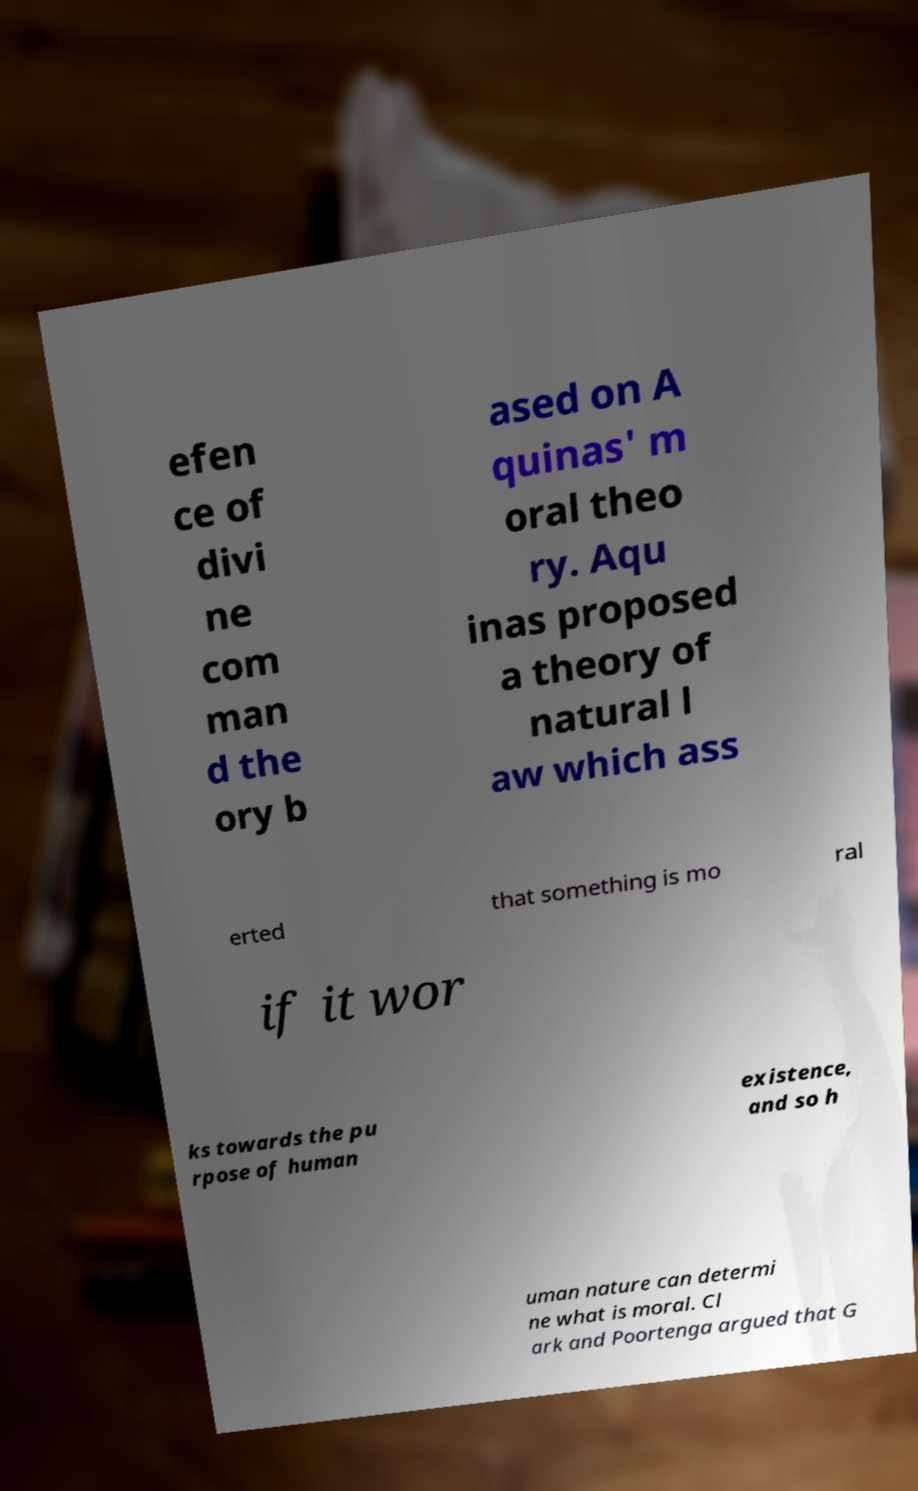There's text embedded in this image that I need extracted. Can you transcribe it verbatim? efen ce of divi ne com man d the ory b ased on A quinas' m oral theo ry. Aqu inas proposed a theory of natural l aw which ass erted that something is mo ral if it wor ks towards the pu rpose of human existence, and so h uman nature can determi ne what is moral. Cl ark and Poortenga argued that G 